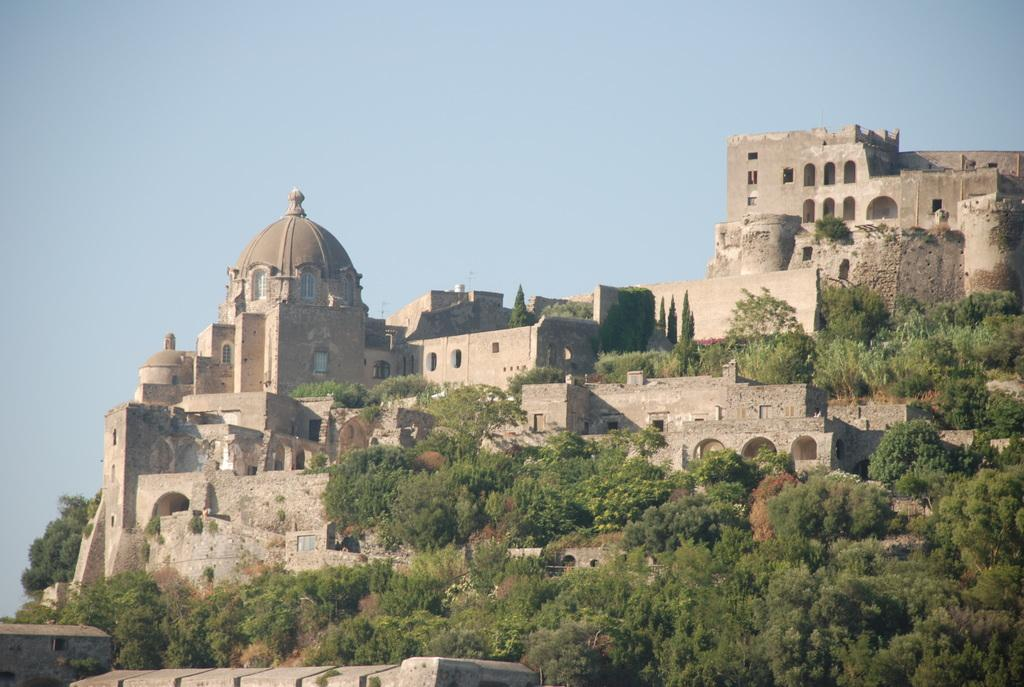What type of vegetation can be seen in the image? There are trees in the image. What is the color of the trees? The trees are green. What can be seen in the background of the image? There are buildings in the background of the image. What colors are the buildings? The buildings are in brown and cream colors. What is visible in the sky in the image? The sky is blue. What type of punishment is being handed out in the image? There is no indication of punishment in the image; it features trees, buildings, and a blue sky. What tool is being used to level the ground in the image? There is no tool or activity related to leveling the ground present in the image. 